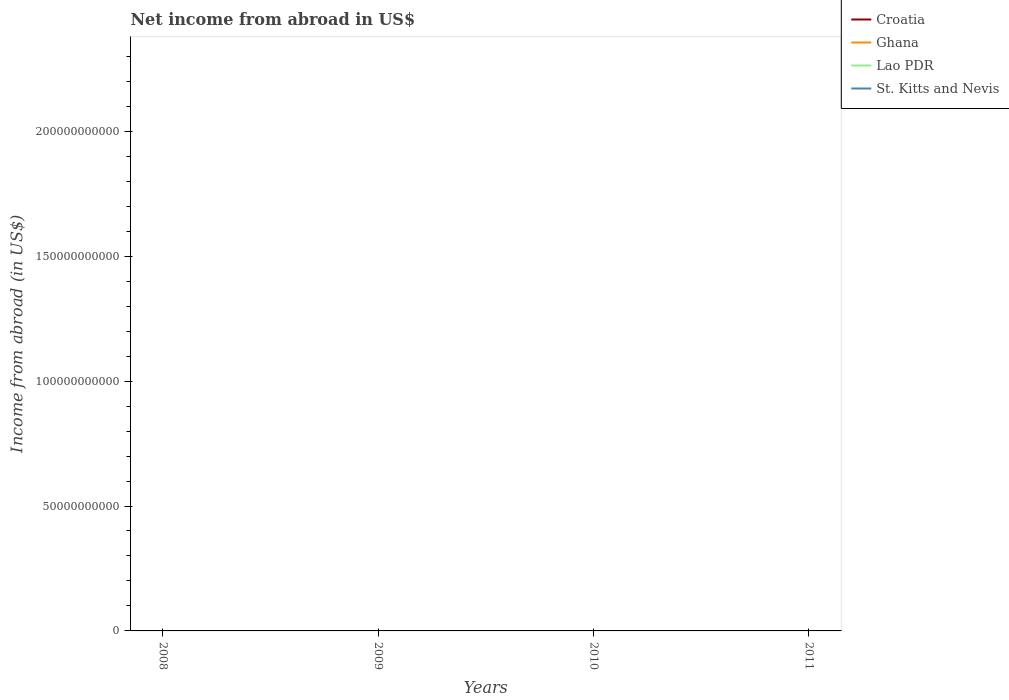Does the line corresponding to Croatia intersect with the line corresponding to St. Kitts and Nevis?
Provide a succinct answer. No. Is the number of lines equal to the number of legend labels?
Your answer should be very brief. No. Is the net income from abroad in St. Kitts and Nevis strictly greater than the net income from abroad in Croatia over the years?
Give a very brief answer. No. How many lines are there?
Give a very brief answer. 0. What is the difference between two consecutive major ticks on the Y-axis?
Your answer should be very brief. 5.00e+1. Are the values on the major ticks of Y-axis written in scientific E-notation?
Make the answer very short. No. Does the graph contain any zero values?
Your response must be concise. Yes. Where does the legend appear in the graph?
Provide a short and direct response. Top right. How are the legend labels stacked?
Provide a short and direct response. Vertical. What is the title of the graph?
Your answer should be very brief. Net income from abroad in US$. Does "Lesotho" appear as one of the legend labels in the graph?
Make the answer very short. No. What is the label or title of the X-axis?
Offer a very short reply. Years. What is the label or title of the Y-axis?
Provide a succinct answer. Income from abroad (in US$). What is the Income from abroad (in US$) in Croatia in 2008?
Your answer should be very brief. 0. What is the Income from abroad (in US$) of Lao PDR in 2008?
Offer a very short reply. 0. What is the Income from abroad (in US$) in St. Kitts and Nevis in 2008?
Your answer should be compact. 0. What is the Income from abroad (in US$) of Croatia in 2009?
Provide a short and direct response. 0. What is the Income from abroad (in US$) in Ghana in 2009?
Provide a succinct answer. 0. What is the Income from abroad (in US$) of Ghana in 2010?
Offer a terse response. 0. What is the Income from abroad (in US$) in Lao PDR in 2010?
Give a very brief answer. 0. What is the Income from abroad (in US$) in St. Kitts and Nevis in 2010?
Your answer should be compact. 0. What is the total Income from abroad (in US$) of Ghana in the graph?
Provide a succinct answer. 0. What is the average Income from abroad (in US$) of Croatia per year?
Your answer should be compact. 0. What is the average Income from abroad (in US$) of Ghana per year?
Your answer should be very brief. 0. What is the average Income from abroad (in US$) of St. Kitts and Nevis per year?
Provide a short and direct response. 0. 